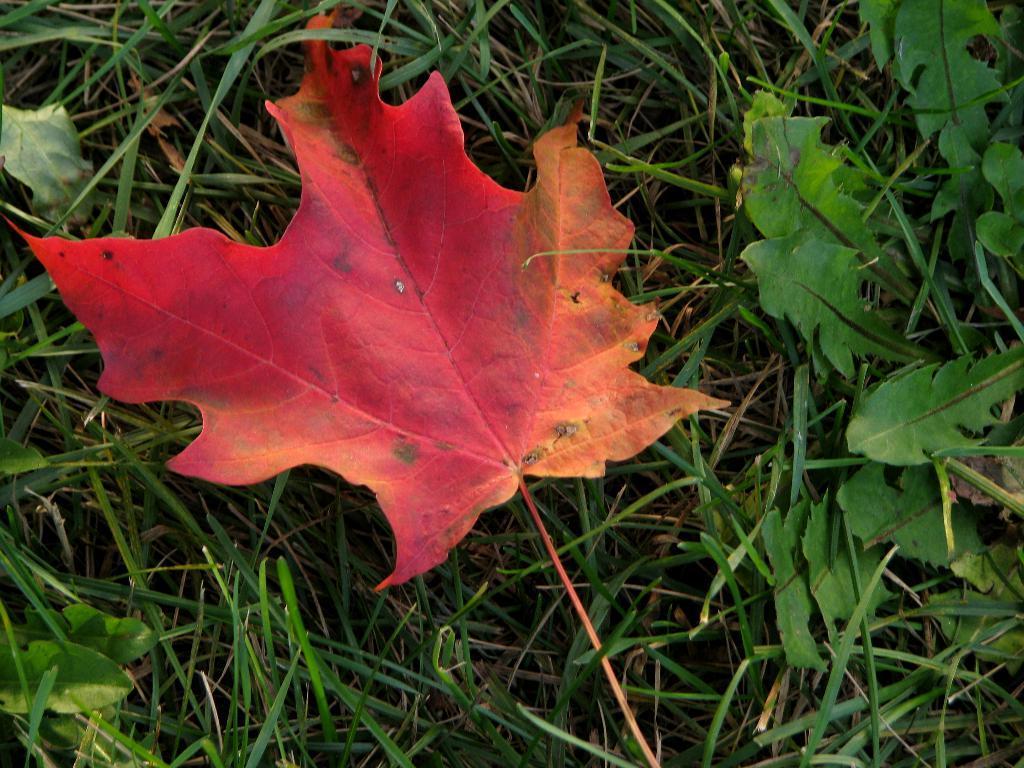Describe this image in one or two sentences. In this image, we can see leaves and grass. 